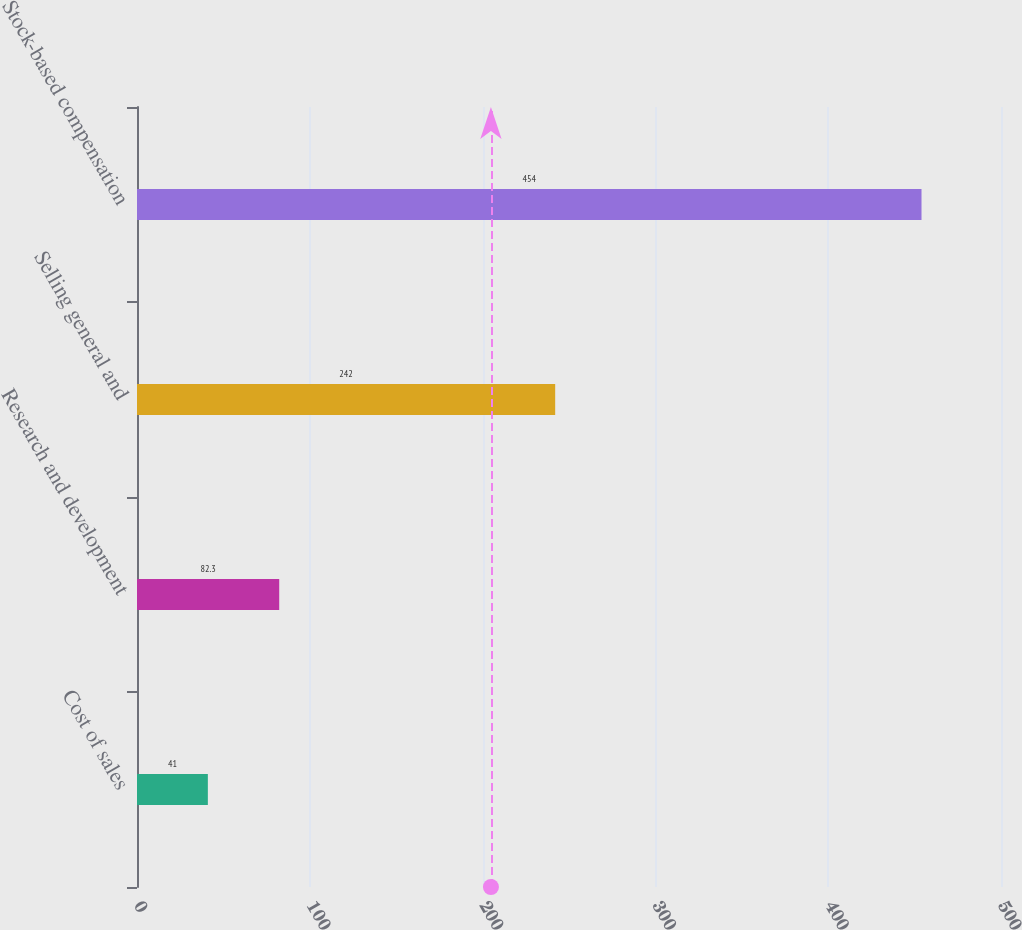Convert chart. <chart><loc_0><loc_0><loc_500><loc_500><bar_chart><fcel>Cost of sales<fcel>Research and development<fcel>Selling general and<fcel>Stock-based compensation<nl><fcel>41<fcel>82.3<fcel>242<fcel>454<nl></chart> 